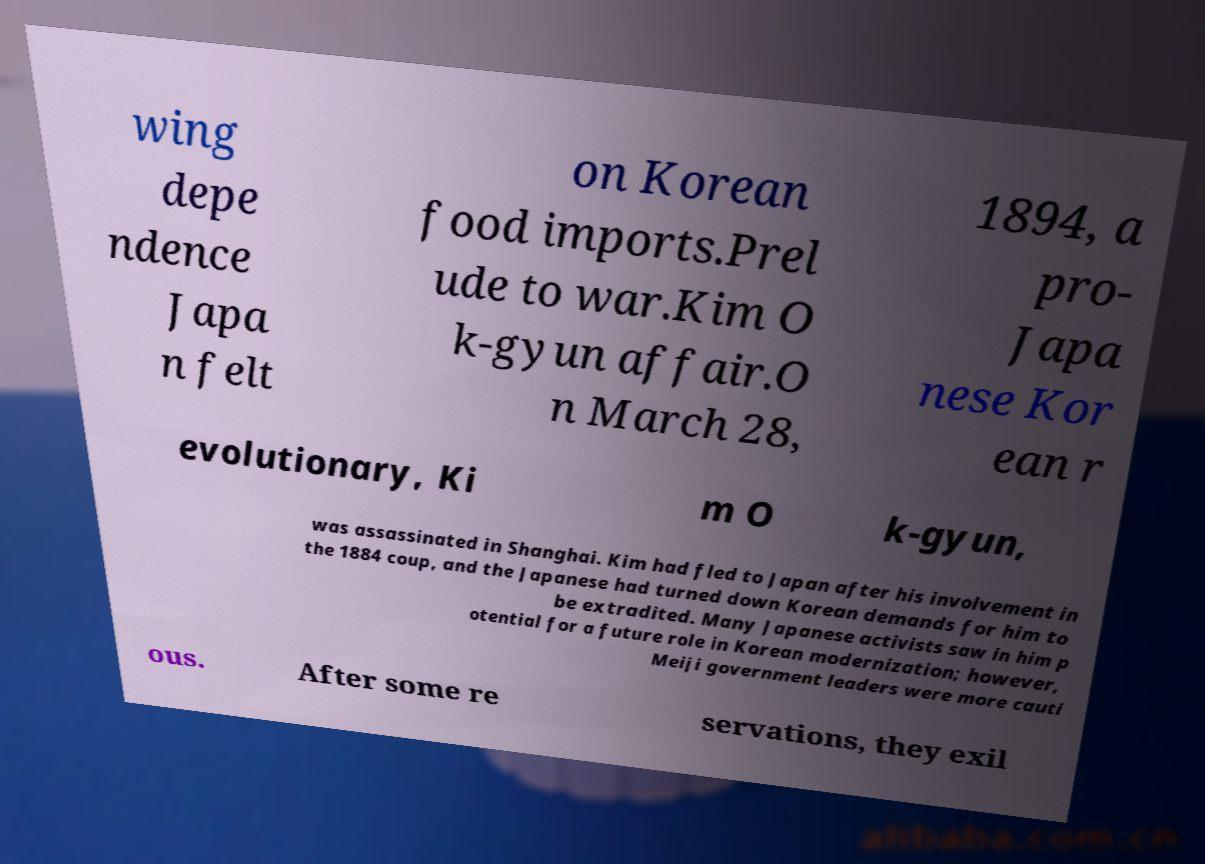For documentation purposes, I need the text within this image transcribed. Could you provide that? wing depe ndence Japa n felt on Korean food imports.Prel ude to war.Kim O k-gyun affair.O n March 28, 1894, a pro- Japa nese Kor ean r evolutionary, Ki m O k-gyun, was assassinated in Shanghai. Kim had fled to Japan after his involvement in the 1884 coup, and the Japanese had turned down Korean demands for him to be extradited. Many Japanese activists saw in him p otential for a future role in Korean modernization; however, Meiji government leaders were more cauti ous. After some re servations, they exil 